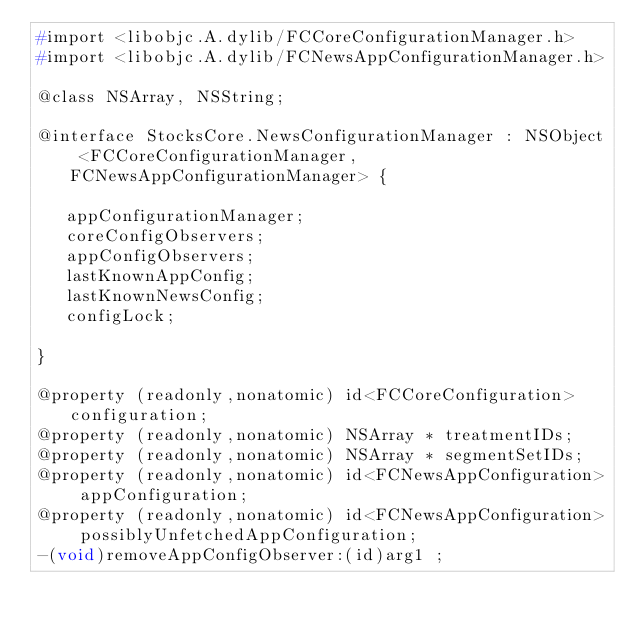<code> <loc_0><loc_0><loc_500><loc_500><_C_>#import <libobjc.A.dylib/FCCoreConfigurationManager.h>
#import <libobjc.A.dylib/FCNewsAppConfigurationManager.h>

@class NSArray, NSString;

@interface StocksCore.NewsConfigurationManager : NSObject <FCCoreConfigurationManager, FCNewsAppConfigurationManager> {

	 appConfigurationManager;
	 coreConfigObservers;
	 appConfigObservers;
	 lastKnownAppConfig;
	 lastKnownNewsConfig;
	 configLock;

}

@property (readonly,nonatomic) id<FCCoreConfiguration> configuration; 
@property (readonly,nonatomic) NSArray * treatmentIDs; 
@property (readonly,nonatomic) NSArray * segmentSetIDs; 
@property (readonly,nonatomic) id<FCNewsAppConfiguration> appConfiguration; 
@property (readonly,nonatomic) id<FCNewsAppConfiguration> possiblyUnfetchedAppConfiguration; 
-(void)removeAppConfigObserver:(id)arg1 ;</code> 